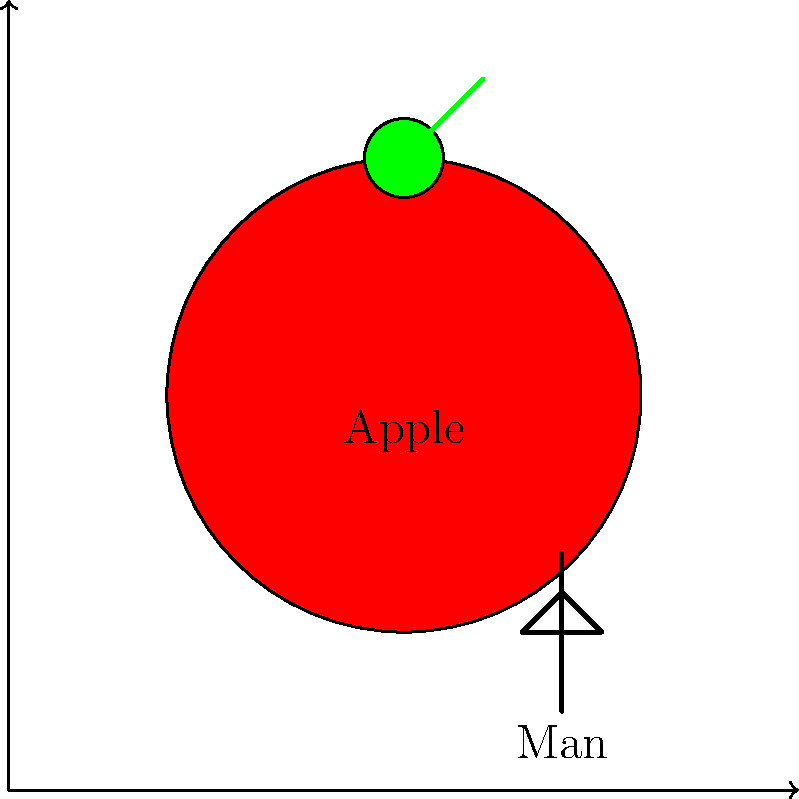In Magritte's painting "The Listening Room" (1952), a giant apple fills an entire room. Based on the provided diagram inspired by this work, estimate the ratio of the apple's height to the man's height. How does this extreme difference in scale contribute to the surrealist nature of Magritte's landscapes? To answer this question, let's break it down step-by-step:

1. Observe the diagram: The image shows a large red apple and a small stick figure representing a man.

2. Estimate heights:
   - The apple's diameter is approximately 6 units.
   - The man's height is approximately 2 units.

3. Calculate the ratio:
   Apple height : Man height = 6 : 2
   This can be simplified to 3 : 1

4. Interpret the scale difference:
   The apple is about three times taller than the man, creating a surreal and impossible scenario in reality.

5. Understand Magritte's use of scale:
   - Magritte often used unexpected scale relationships to challenge viewers' perceptions.
   - By making everyday objects enormous compared to human figures, he created a sense of disorientation and dreamlike atmosphere.
   - This manipulation of scale disrupts our normal understanding of spatial relationships, forcing us to question our perception of reality.

6. Surrealist landscape contribution:
   - The extreme difference in scale immediately creates a sense of the impossible or supernatural.
   - It transforms a familiar object (an apple) into something monumental and potentially threatening.
   - This juxtaposition of sizes creates a psychological tension, typical of surrealist art.
   - The distorted proportions invite viewers to reconsider their relationship with everyday objects and spaces.

7. Art historical context:
   Magritte's use of scale is part of the broader surrealist movement's aim to explore the subconscious and challenge rational thought through unexpected visual combinations.
Answer: 3:1 ratio; creates disorientation and dreamlike atmosphere, challenging perception of reality 